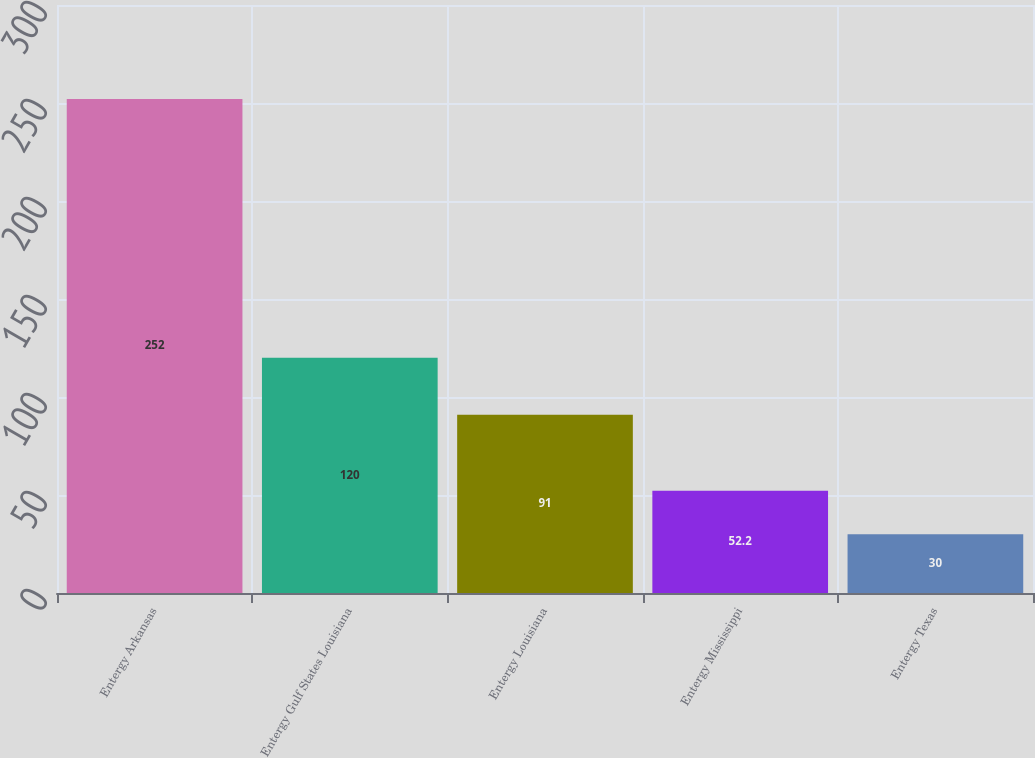Convert chart. <chart><loc_0><loc_0><loc_500><loc_500><bar_chart><fcel>Entergy Arkansas<fcel>Entergy Gulf States Louisiana<fcel>Entergy Louisiana<fcel>Entergy Mississippi<fcel>Entergy Texas<nl><fcel>252<fcel>120<fcel>91<fcel>52.2<fcel>30<nl></chart> 